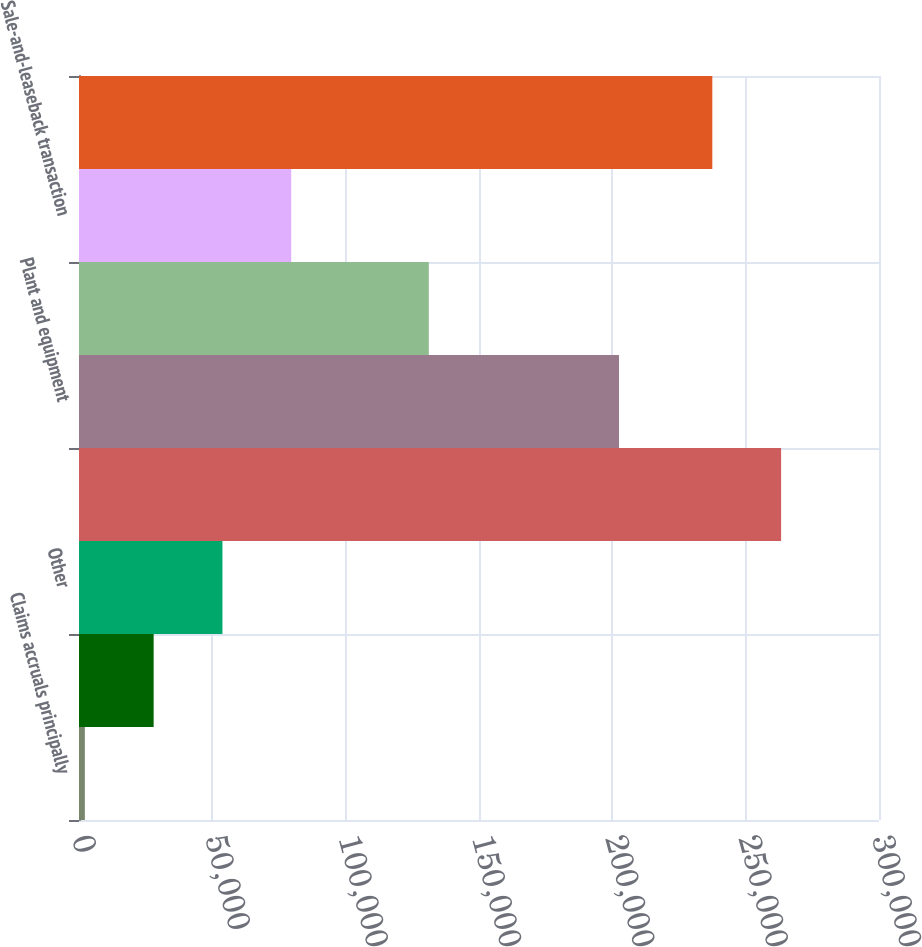Convert chart to OTSL. <chart><loc_0><loc_0><loc_500><loc_500><bar_chart><fcel>Claims accruals principally<fcel>Accounts receivable<fcel>Other<fcel>Total gross deferred tax<fcel>Plant and equipment<fcel>Prepaid permits and insurance<fcel>Sale-and-leaseback transaction<fcel>Net deferred tax liability<nl><fcel>2198<fcel>27994.1<fcel>53790.2<fcel>263289<fcel>202508<fcel>131178<fcel>79586.3<fcel>237493<nl></chart> 